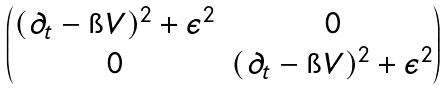Convert formula to latex. <formula><loc_0><loc_0><loc_500><loc_500>\begin{pmatrix} ( \partial _ { t } - \i V ) ^ { 2 } + \epsilon ^ { 2 } & 0 \\ 0 & ( \partial _ { t } - \i V ) ^ { 2 } + \epsilon ^ { 2 } \end{pmatrix}</formula> 